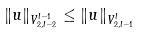Convert formula to latex. <formula><loc_0><loc_0><loc_500><loc_500>\| u \| _ { V ^ { l - 1 } _ { 2 , l - 2 } } \leq \| u \| _ { V ^ { l } _ { 2 , l - 1 } }</formula> 